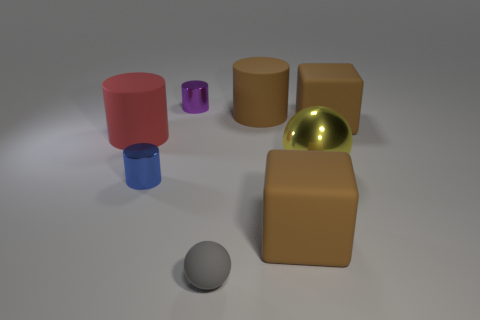Which object stands out the most, and why? The shiny yellow metallic ball stands out the most due to its reflective surface that catches the light, contrasting with the matte textures of the other objects. Its color also differs significantly from the more earth-toned cylinders and the neutral background. If I wanted to compare the textures of the objects, how would you describe them? The textures in the image vary widely. The cylinders exhibit a matte finish that diffuses light evenly, notably the beige and pink ones. The purple and blue cylinders share a similar matte texture but are smaller in scale. The grey sphere displays a semi-matte surface, while the yellow ball has a highly reflective metallic texture that creates distinct light reflections and appears smooth. 